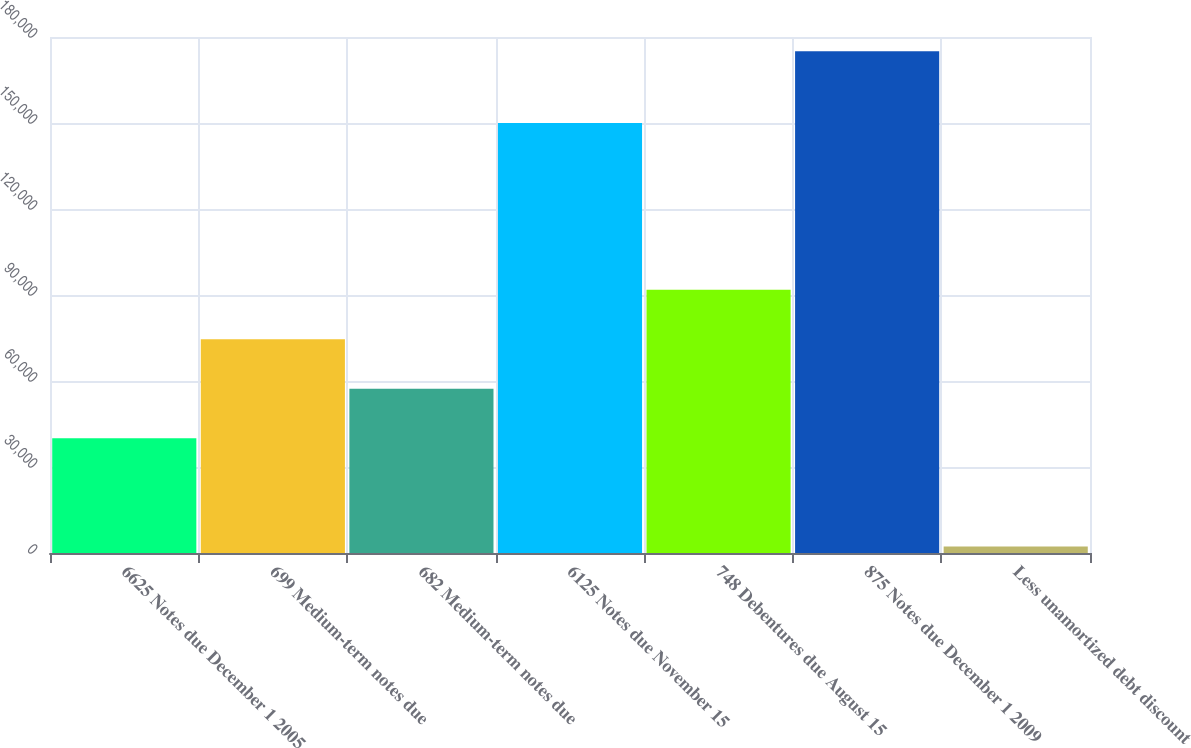Convert chart. <chart><loc_0><loc_0><loc_500><loc_500><bar_chart><fcel>6625 Notes due December 1 2005<fcel>699 Medium-term notes due<fcel>682 Medium-term notes due<fcel>6125 Notes due November 15<fcel>748 Debentures due August 15<fcel>875 Notes due December 1 2009<fcel>Less unamortized debt discount<nl><fcel>40000<fcel>74550<fcel>57275<fcel>150000<fcel>91825<fcel>175000<fcel>2250<nl></chart> 